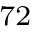Convert formula to latex. <formula><loc_0><loc_0><loc_500><loc_500>^ { 7 2 }</formula> 